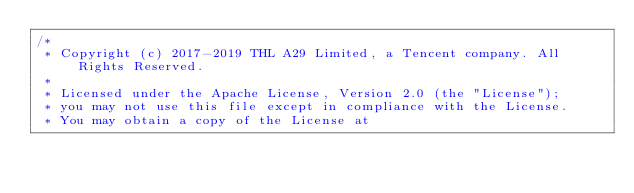Convert code to text. <code><loc_0><loc_0><loc_500><loc_500><_C++_>/*
 * Copyright (c) 2017-2019 THL A29 Limited, a Tencent company. All Rights Reserved.
 *
 * Licensed under the Apache License, Version 2.0 (the "License");
 * you may not use this file except in compliance with the License.
 * You may obtain a copy of the License at</code> 